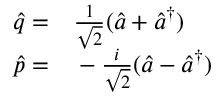Convert formula to latex. <formula><loc_0><loc_0><loc_500><loc_500>\begin{array} { r l } { \hat { q } = } & \frac { 1 } { \sqrt { 2 } } ( \hat { a } + \hat { a } ^ { \dagger } ) } \\ { \hat { p } = } & - \frac { i } { \sqrt { 2 } } ( \hat { a } - \hat { a } ^ { \dagger } ) } \end{array}</formula> 